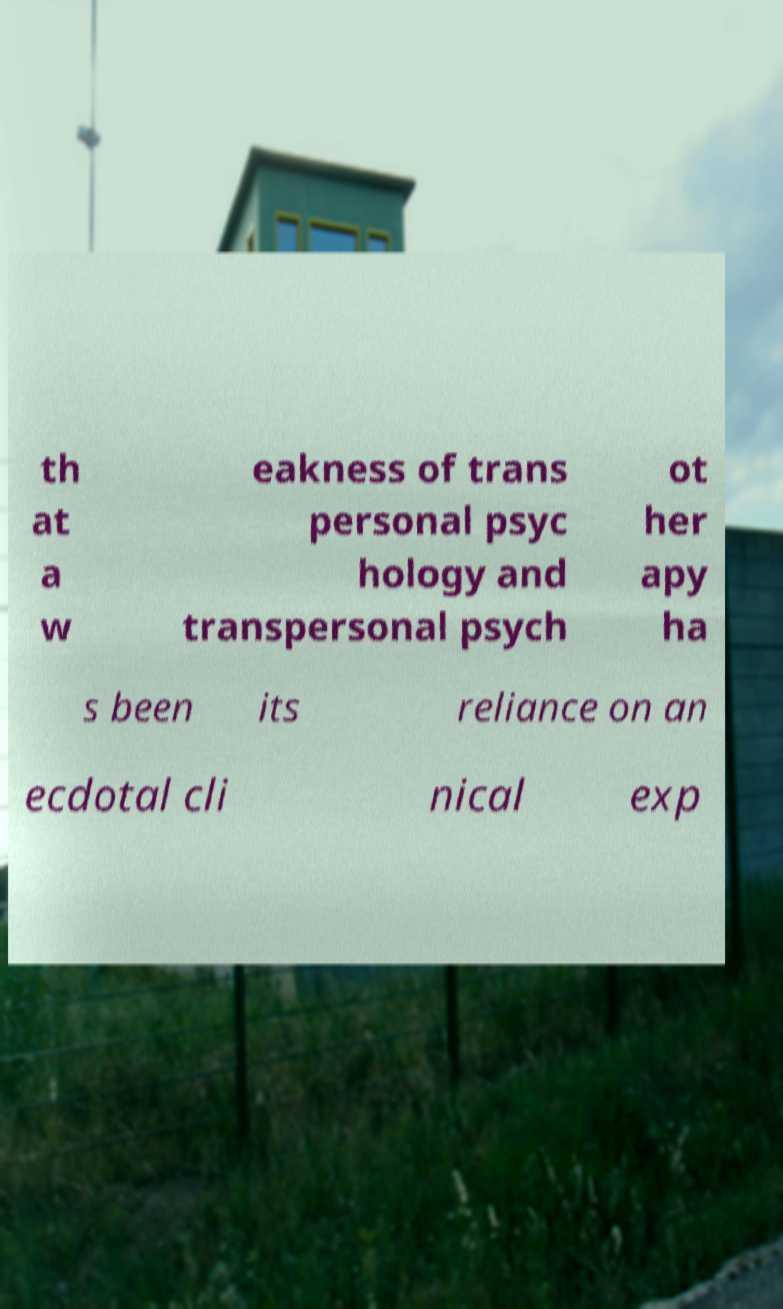Please read and relay the text visible in this image. What does it say? th at a w eakness of trans personal psyc hology and transpersonal psych ot her apy ha s been its reliance on an ecdotal cli nical exp 